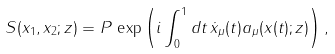Convert formula to latex. <formula><loc_0><loc_0><loc_500><loc_500>S ( x _ { 1 } , x _ { 2 } ; z ) = P \, \exp \left ( i \int ^ { 1 } _ { 0 } d t \, \dot { x } _ { \mu } ( t ) a _ { \mu } ( x ( t ) ; z ) \right ) ,</formula> 